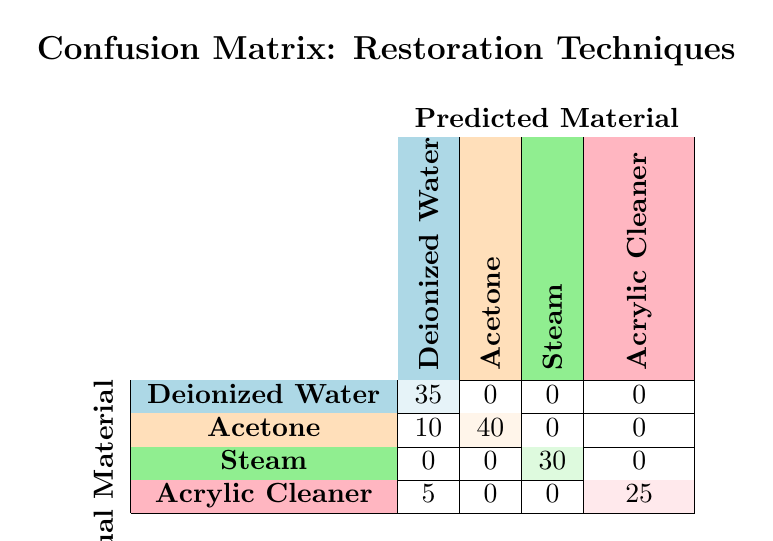What is the accuracy of Ultrasound Cleaning in identifying Deionized Water? The accuracy can be obtained from the count of correctly predicted materials (35 for Deionized Water) out of the total predictions made for that material. Since there are only 35 predictions made for Deionized Water, the accuracy is 35/35 = 100%.
Answer: 100% What is the total number of times Acetone was correctly predicted by the Chemical Cleaning technique? From the table, the count for Acetone under Chemical Cleaning (correct prediction) is 40.
Answer: 40 Is it true that Steam Cleaning accurately predicted all of its actual cleaning materials? Yes, upon checking the table, Steam Cleaning has a count of 30 for Steam (correct prediction) and has no incorrect predictions. Therefore, it accurately predicted all its materials.
Answer: Yes What is the total count of predicted materials for Dry Cleaning? To find this, we add up the counts from the Dry Cleaning rows: 25 (Acrylic Cleaner) + 5 (Deionized Water) = 30.
Answer: 30 How many instances were Deionized Water incorrectly predicted by the Chemical Cleaning technique? The table shows that Deionized Water was incorrectly predicted as Acetone 10 times (from the count under Chemical Cleaning).
Answer: 10 Which cleaning technique had the highest number of correct predictions overall? Total counts per technique: Ultrasonic Cleaning has 35, Chemical Cleaning has 40, Steam Cleaning has 30, Dry Cleaning has 25. Chemical Cleaning had the highest with 40.
Answer: Chemical Cleaning What is the total number of incorrect predictions for Acrylic Cleaner? Incorrect predictions for Acrylic Cleaner are counted under other techniques: 5 (from Dry Cleaning). Summing these gives us the total incorrect predictions: 5.
Answer: 5 Did any cleaning technique predict more than one material correctly? No, in the table each technique only has counts for one correct material and the corresponding incorrect counts for others but does not predict multiple materials accurately.
Answer: No 